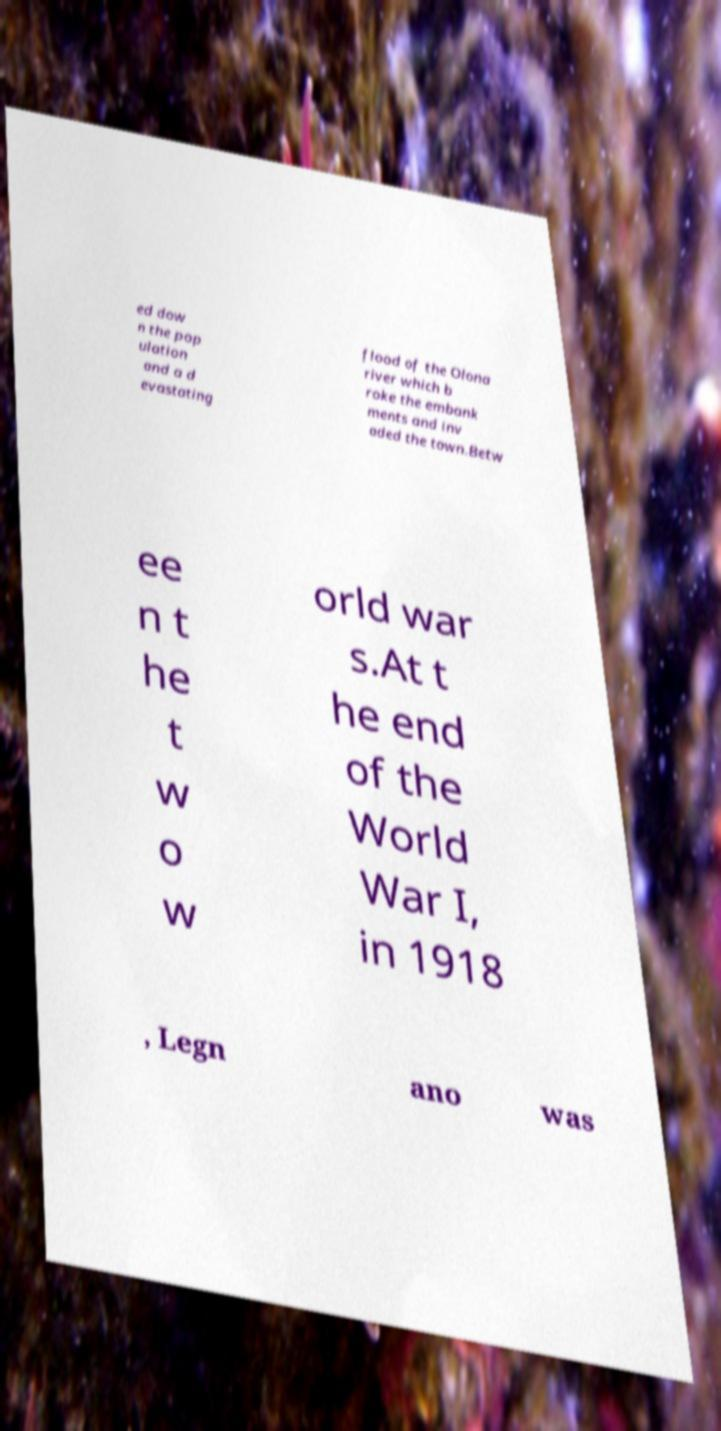Can you read and provide the text displayed in the image?This photo seems to have some interesting text. Can you extract and type it out for me? ed dow n the pop ulation and a d evastating flood of the Olona river which b roke the embank ments and inv aded the town.Betw ee n t he t w o w orld war s.At t he end of the World War I, in 1918 , Legn ano was 